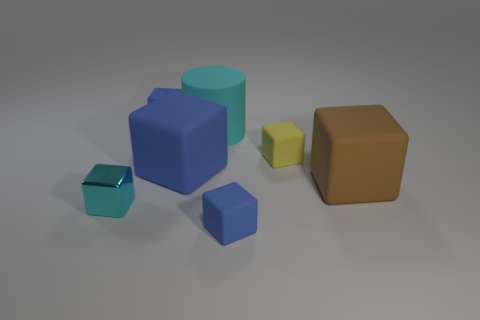What is the material of the tiny thing that is the same color as the large cylinder?
Ensure brevity in your answer.  Metal. How many matte things are the same color as the metallic cube?
Give a very brief answer. 1. Does the metal object have the same color as the large matte cylinder?
Your answer should be compact. Yes. Is there any other thing that is the same shape as the big cyan object?
Ensure brevity in your answer.  No. Does the blue matte block in front of the cyan block have the same size as the large blue block?
Keep it short and to the point. No. What material is the cyan object that is in front of the big cyan rubber cylinder?
Offer a very short reply. Metal. Are there more small green metallic things than objects?
Your answer should be compact. No. What number of objects are small matte objects that are behind the brown object or small cyan things?
Offer a terse response. 3. There is a small blue object right of the cylinder; how many small blue objects are right of it?
Give a very brief answer. 0. What size is the cyan thing that is right of the small block on the left side of the small rubber thing behind the small yellow matte object?
Your answer should be very brief. Large. 